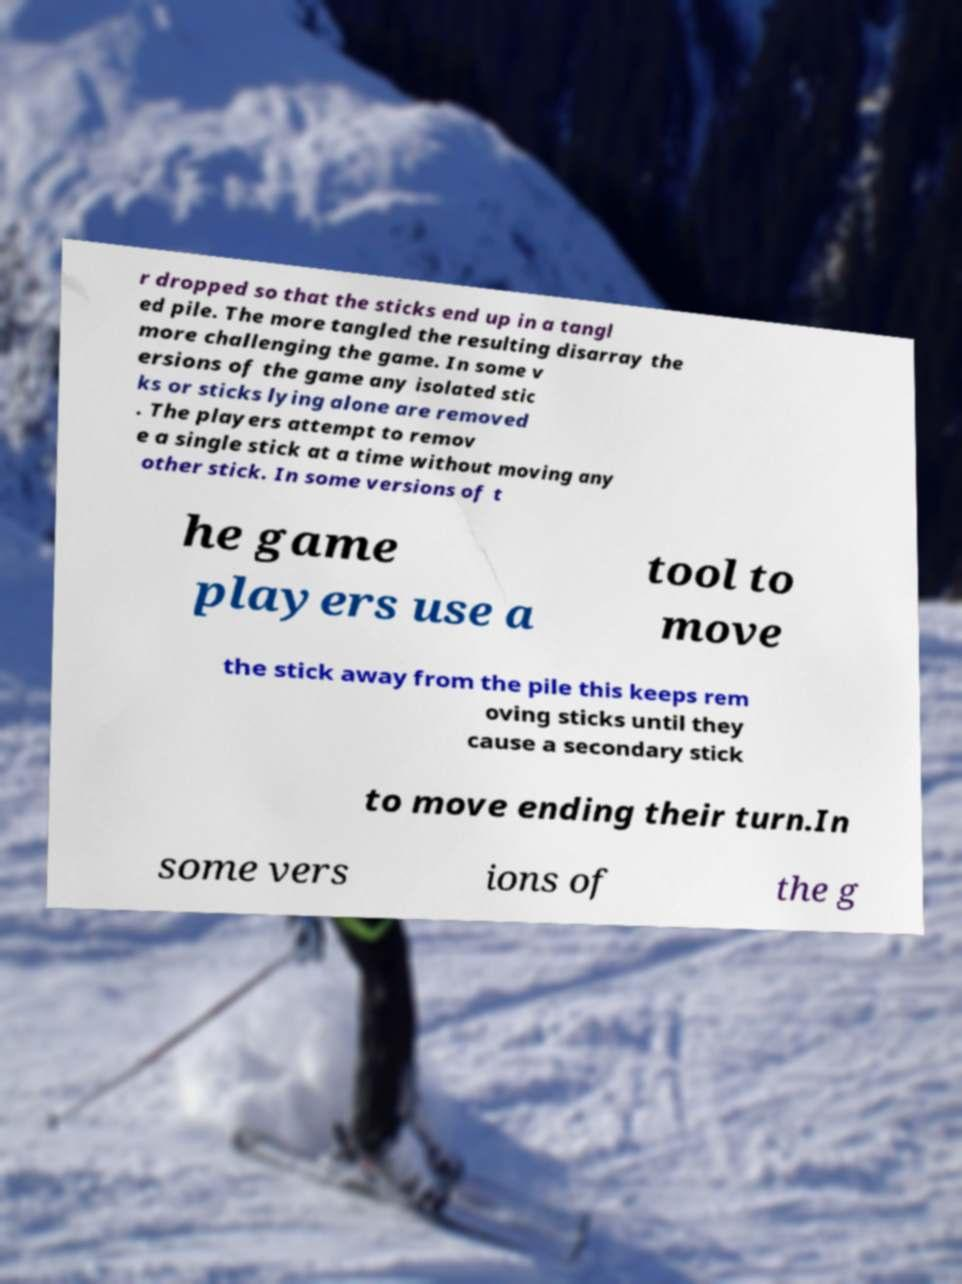For documentation purposes, I need the text within this image transcribed. Could you provide that? r dropped so that the sticks end up in a tangl ed pile. The more tangled the resulting disarray the more challenging the game. In some v ersions of the game any isolated stic ks or sticks lying alone are removed . The players attempt to remov e a single stick at a time without moving any other stick. In some versions of t he game players use a tool to move the stick away from the pile this keeps rem oving sticks until they cause a secondary stick to move ending their turn.In some vers ions of the g 